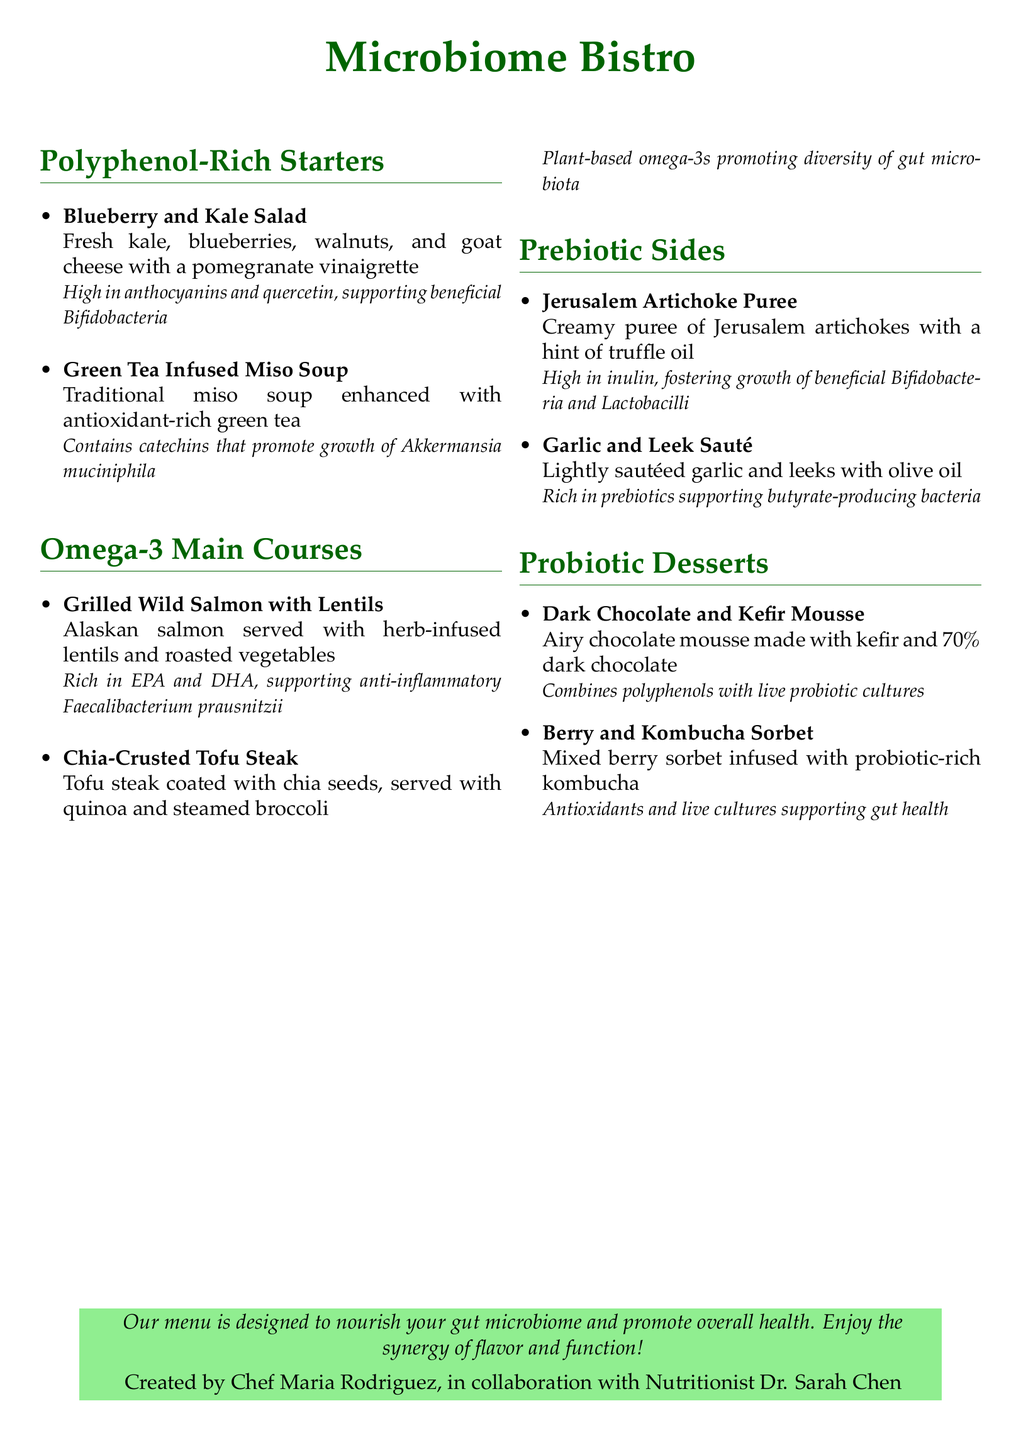What is the name of the bistro? The name of the bistro is prominently mentioned at the top of the document.
Answer: Microbiome Bistro Who created the menu? The menu is created by Chef Maria Rodriguez in collaboration with a nutritionist.
Answer: Chef Maria Rodriguez What is the main ingredient in the Blueberry and Kale Salad? The main ingredients of the Blueberry and Kale Salad are listed in the description of the dish.
Answer: Kale Which nutrient is high in the Grilled Wild Salmon? The description identifies specific beneficial compounds found in the Grilled Wild Salmon.
Answer: EPA and DHA What type of seeds is the Chia-Crusted Tofu Steak coated with? The description of the Chia-Crusted Tofu Steak specifies the type of seeds used.
Answer: Chia seeds What kind of soup is enhanced with green tea? The document refers to a specific traditional soup that has been enhanced.
Answer: Miso Soup Which dessert combines polyphenols with live probiotic cultures? The dessert is specifically described to combine two functional ingredients.
Answer: Dark Chocolate and Kefir Mousse What is the primary prebiotic ingredient in the Jerusalem Artichoke Puree? The description highlights the prebiotic component of the puree.
Answer: Inulin How is the Berry and Kombucha Sorbet infused? The method of infusion for this dessert is outlined in its description.
Answer: Probiotic-rich kombucha 